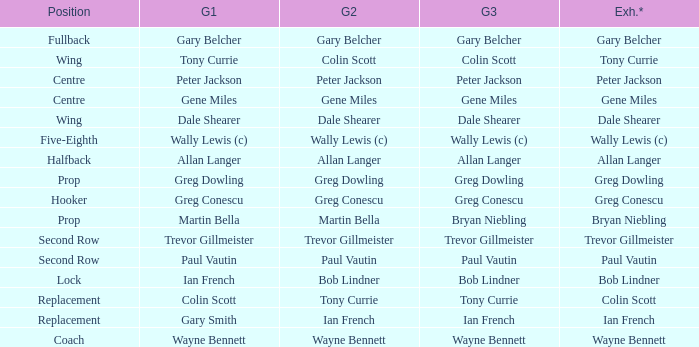What game 1 has bob lindner as game 2? Ian French. 